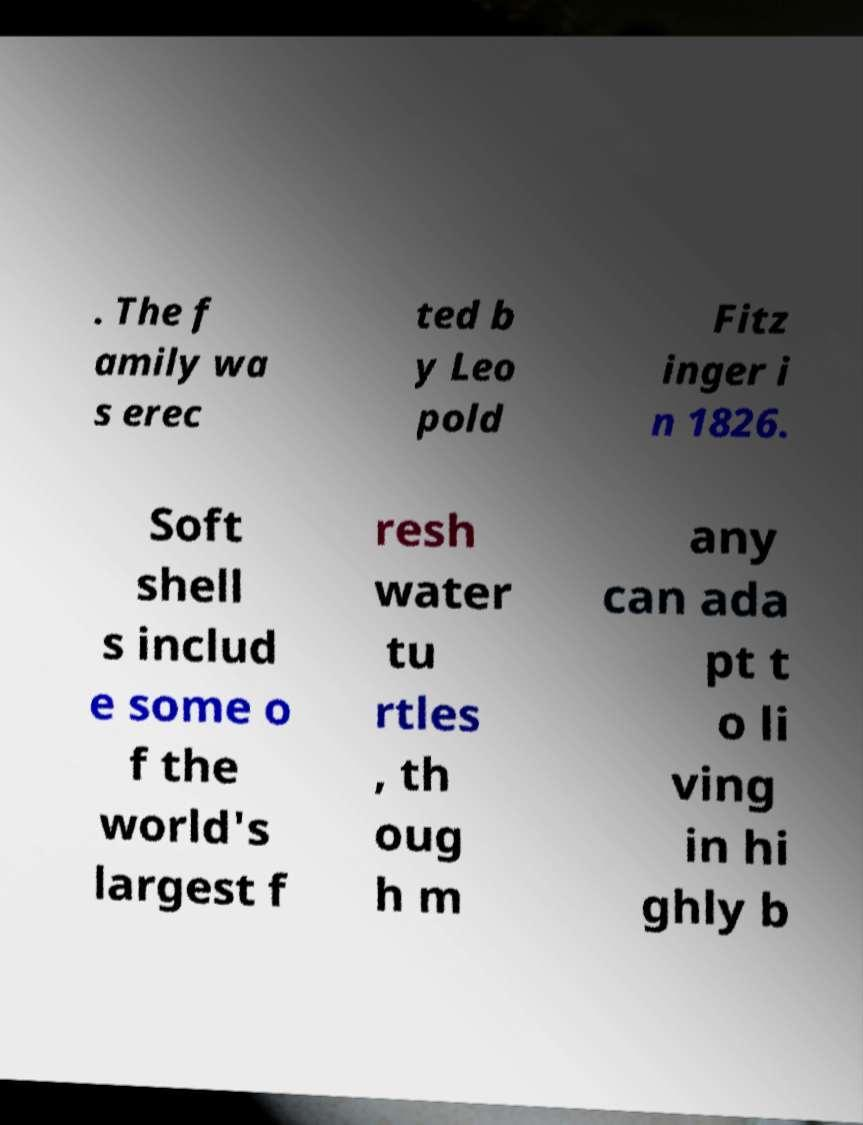Can you read and provide the text displayed in the image?This photo seems to have some interesting text. Can you extract and type it out for me? . The f amily wa s erec ted b y Leo pold Fitz inger i n 1826. Soft shell s includ e some o f the world's largest f resh water tu rtles , th oug h m any can ada pt t o li ving in hi ghly b 